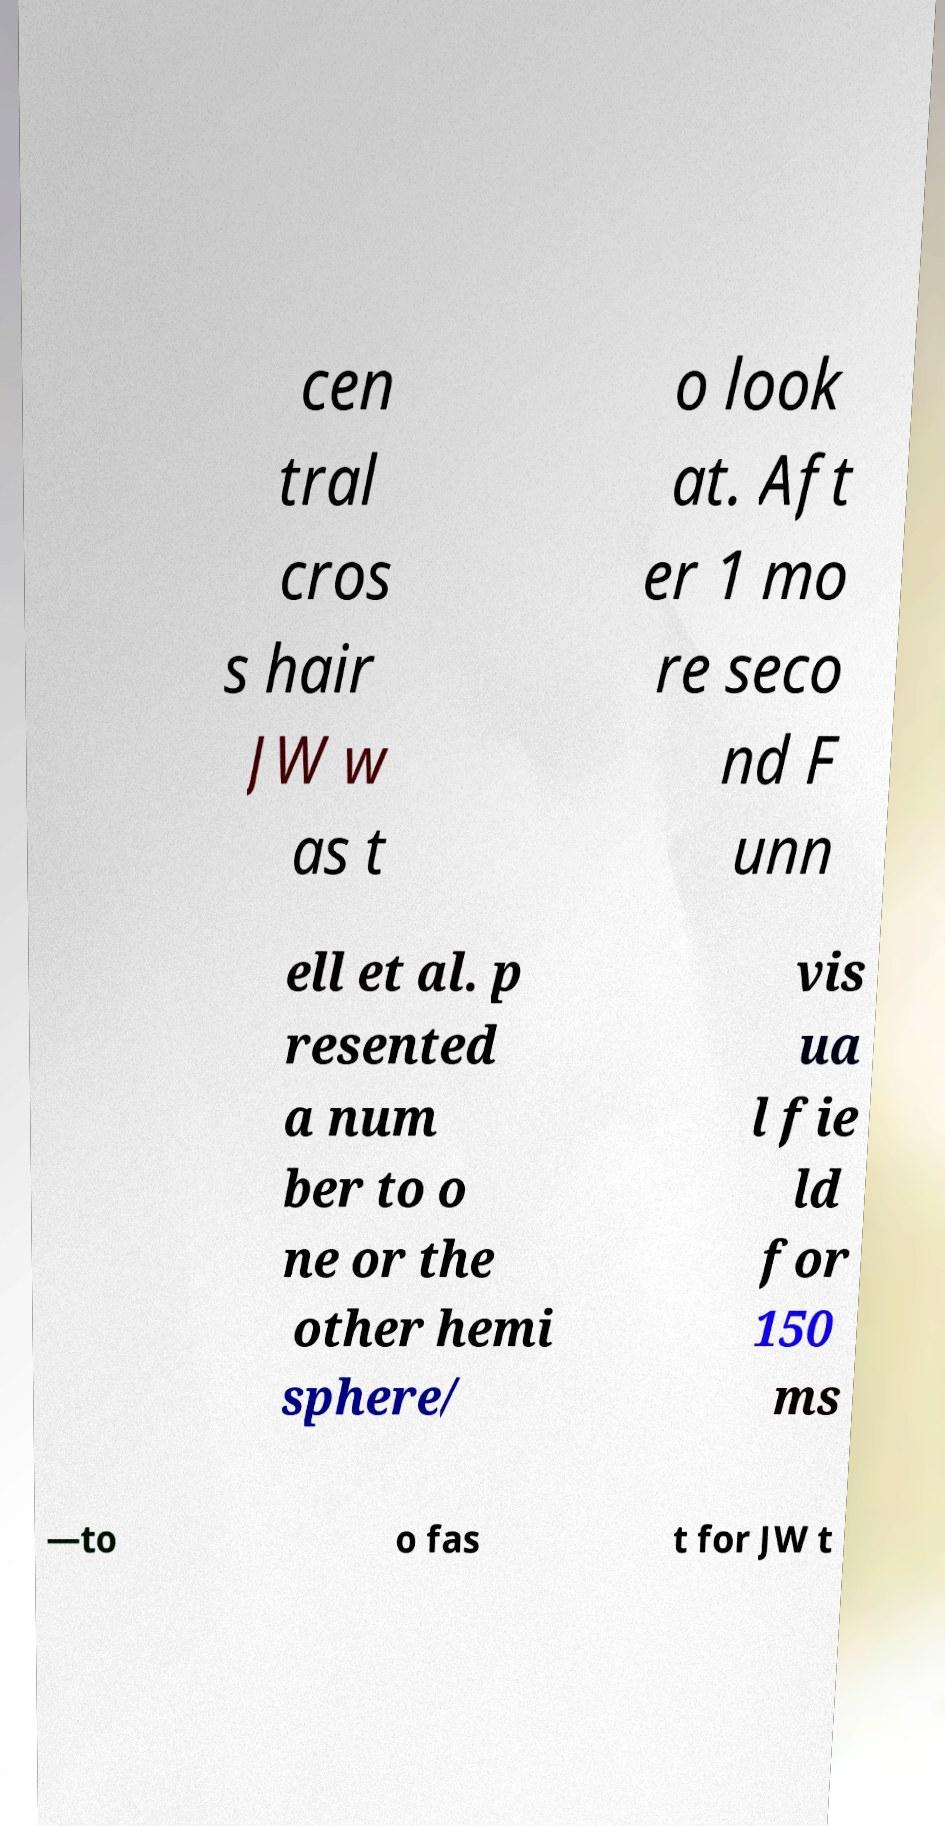Could you extract and type out the text from this image? cen tral cros s hair JW w as t o look at. Aft er 1 mo re seco nd F unn ell et al. p resented a num ber to o ne or the other hemi sphere/ vis ua l fie ld for 150 ms —to o fas t for JW t 